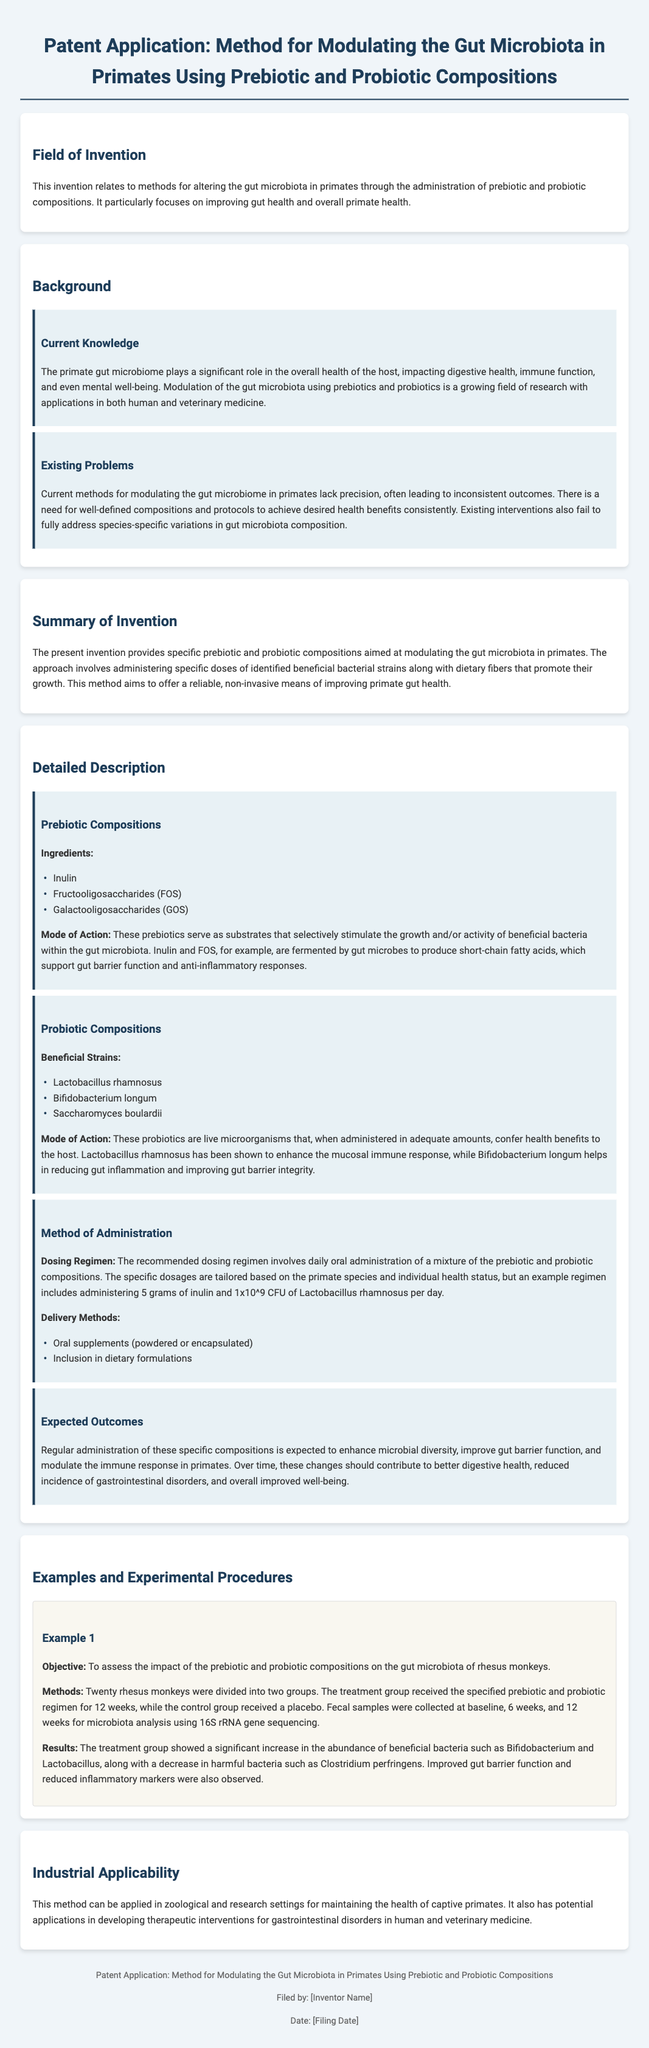What is the field of invention? The field of invention is defined in the document's introductory section, which states methods for altering gut microbiota in primates with prebiotic and probiotic compositions.
Answer: Modulating the gut microbiota in primates using prebiotic and probiotic compositions What are the three prebiotic ingredients listed? The document specifies the ingredients used in the prebiotic compositions, which include Inulin, Fructooligosaccharides (FOS), and Galactooligosaccharides (GOS).
Answer: Inulin, Fructooligosaccharides (FOS), Galactooligosaccharides (GOS) What is the example dosing regimen? The document outlines a specific example regimen that includes dosage information, stating an example involves administering 5 grams of inulin and 1x10^9 CFU of Lactobacillus rhamnosus per day.
Answer: 5 grams of inulin and 1x10^9 CFU of Lactobacillus rhamnosus Which beneficial strain is known to enhance the mucosal immune response? The document mentions specific strains of probiotics and identifies Lactobacillus rhamnosus as one that enhances the mucosal immune response.
Answer: Lactobacillus rhamnosus How many groups were formed in Example 1 of the experimental procedures? The document describes a study design in Example 1, indicating that twenty rhesus monkeys were divided into two groups for the experiment.
Answer: Two groups What are the expected outcomes of the treatment? The document elaborates on the anticipated results, stating that regular administration of the compositions is expected to enhance microbial diversity, improve gut barrier function, and modulate the immune response.
Answer: Enhance microbial diversity, improve gut barrier function, modulate immune response What is the significance of the gut microbiome in primates? The background section highlights the role of the gut microbiome in primate health, stating it impacts digestive health, immune function, and mental well-being.
Answer: Impacts digestive health, immune function, mental well-being What type of document is presented? The entire document is structured as a patent application, which includes sections typically found in such documents like field of invention, background, summary, and detailed description.
Answer: Patent application 